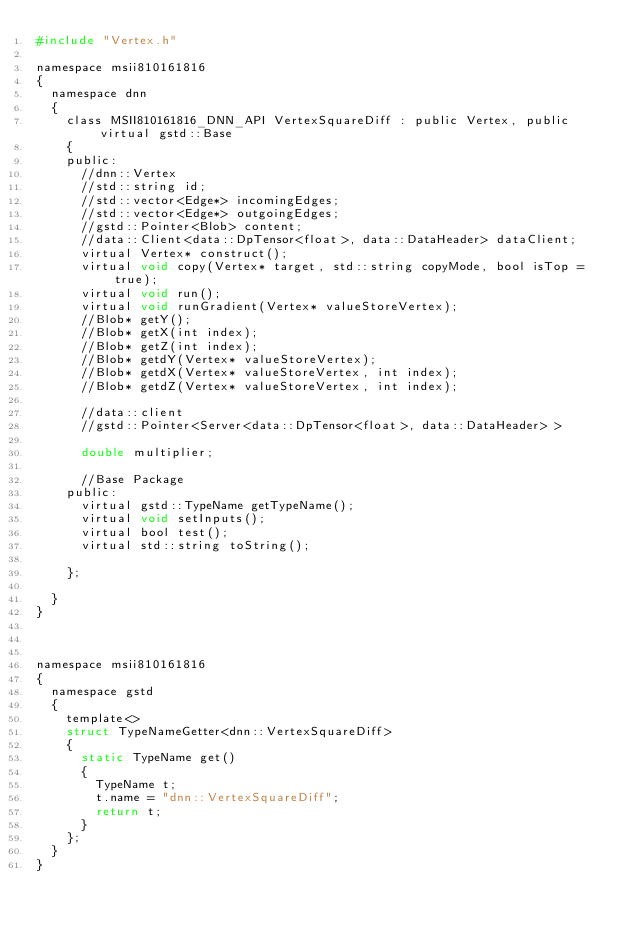<code> <loc_0><loc_0><loc_500><loc_500><_C_>#include "Vertex.h"

namespace msii810161816
{
	namespace dnn
	{
		class MSII810161816_DNN_API VertexSquareDiff : public Vertex, public virtual gstd::Base
		{
		public:
			//dnn::Vertex
			//std::string id;
			//std::vector<Edge*> incomingEdges;
			//std::vector<Edge*> outgoingEdges;
			//gstd::Pointer<Blob> content;
			//data::Client<data::DpTensor<float>, data::DataHeader> dataClient;
			virtual Vertex* construct();
			virtual void copy(Vertex* target, std::string copyMode, bool isTop = true);
			virtual void run();
			virtual void runGradient(Vertex* valueStoreVertex);
			//Blob* getY();
			//Blob* getX(int index);
			//Blob* getZ(int index);
			//Blob* getdY(Vertex* valueStoreVertex);
			//Blob* getdX(Vertex* valueStoreVertex, int index);
			//Blob* getdZ(Vertex* valueStoreVertex, int index);

			//data::client
			//gstd::Pointer<Server<data::DpTensor<float>, data::DataHeader> >	

			double multiplier;

			//Base Package    
		public:
			virtual gstd::TypeName getTypeName();
			virtual void setInputs();
			virtual bool test();
			virtual std::string toString();

		};

	}
}



namespace msii810161816
{
	namespace gstd
	{
		template<>
		struct TypeNameGetter<dnn::VertexSquareDiff>
		{
			static TypeName get()
			{
				TypeName t;
				t.name = "dnn::VertexSquareDiff";
				return t;
			}
		};
	}
}</code> 